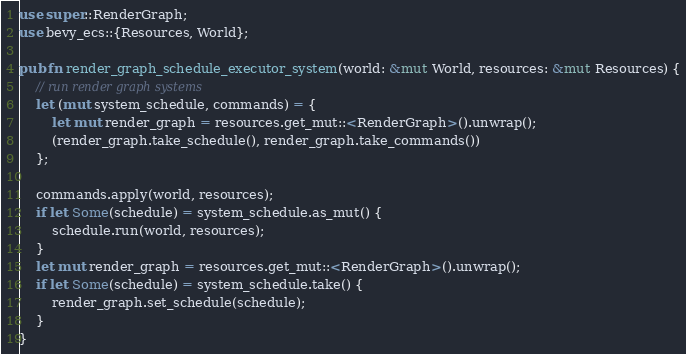<code> <loc_0><loc_0><loc_500><loc_500><_Rust_>use super::RenderGraph;
use bevy_ecs::{Resources, World};

pub fn render_graph_schedule_executor_system(world: &mut World, resources: &mut Resources) {
    // run render graph systems
    let (mut system_schedule, commands) = {
        let mut render_graph = resources.get_mut::<RenderGraph>().unwrap();
        (render_graph.take_schedule(), render_graph.take_commands())
    };

    commands.apply(world, resources);
    if let Some(schedule) = system_schedule.as_mut() {
        schedule.run(world, resources);
    }
    let mut render_graph = resources.get_mut::<RenderGraph>().unwrap();
    if let Some(schedule) = system_schedule.take() {
        render_graph.set_schedule(schedule);
    }
}
</code> 